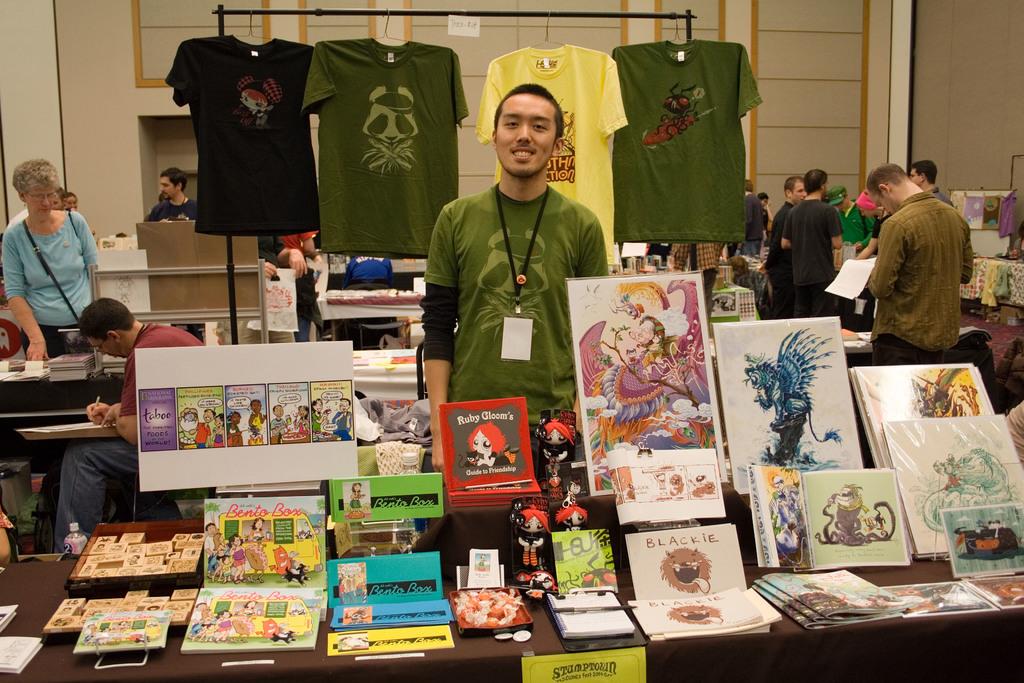What is ruby gloom's guide for?
Your answer should be very brief. Friendship. 